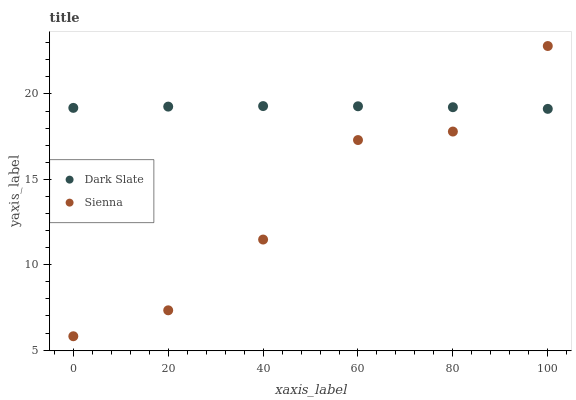Does Sienna have the minimum area under the curve?
Answer yes or no. Yes. Does Dark Slate have the maximum area under the curve?
Answer yes or no. Yes. Does Dark Slate have the minimum area under the curve?
Answer yes or no. No. Is Dark Slate the smoothest?
Answer yes or no. Yes. Is Sienna the roughest?
Answer yes or no. Yes. Is Dark Slate the roughest?
Answer yes or no. No. Does Sienna have the lowest value?
Answer yes or no. Yes. Does Dark Slate have the lowest value?
Answer yes or no. No. Does Sienna have the highest value?
Answer yes or no. Yes. Does Dark Slate have the highest value?
Answer yes or no. No. Does Sienna intersect Dark Slate?
Answer yes or no. Yes. Is Sienna less than Dark Slate?
Answer yes or no. No. Is Sienna greater than Dark Slate?
Answer yes or no. No. 